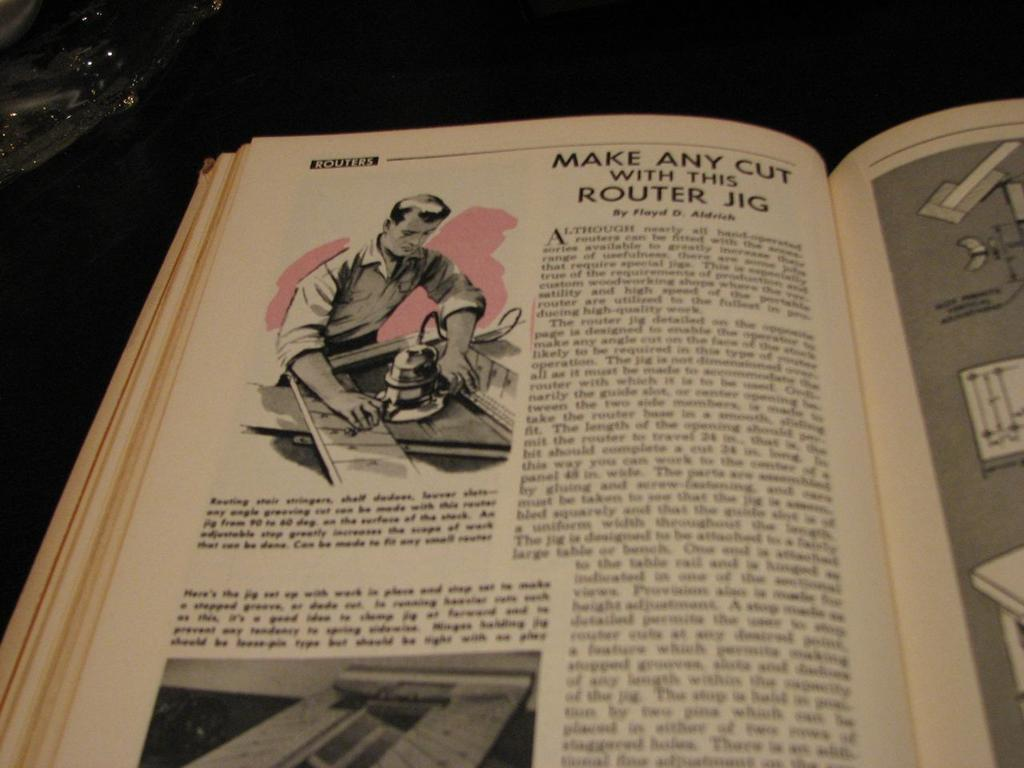<image>
Render a clear and concise summary of the photo. A book is open to a section on routers. 